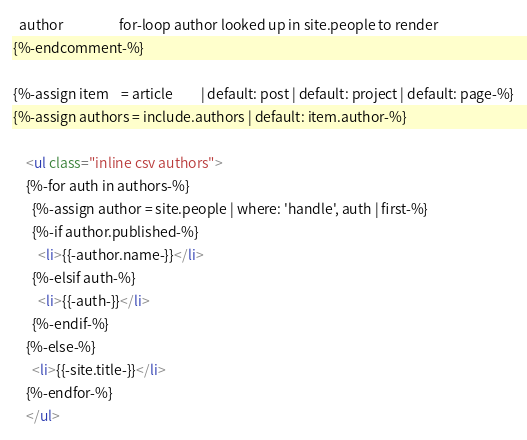Convert code to text. <code><loc_0><loc_0><loc_500><loc_500><_HTML_>  author                  for-loop author looked up in site.people to render
{%-endcomment-%}

{%-assign item    = article         | default: post | default: project | default: page-%}
{%-assign authors = include.authors | default: item.author-%}

    <ul class="inline csv authors">
    {%-for auth in authors-%}
      {%-assign author = site.people | where: 'handle', auth | first-%}
      {%-if author.published-%}
        <li>{{-author.name-}}</li>
      {%-elsif auth-%}
        <li>{{-auth-}}</li>
      {%-endif-%}
    {%-else-%}
      <li>{{-site.title-}}</li>
    {%-endfor-%}
    </ul></code> 